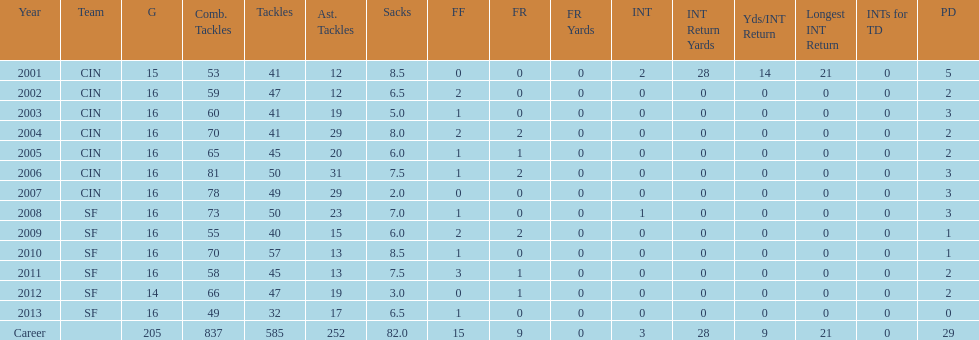How many years did he play where he did not recover a fumble? 7. 